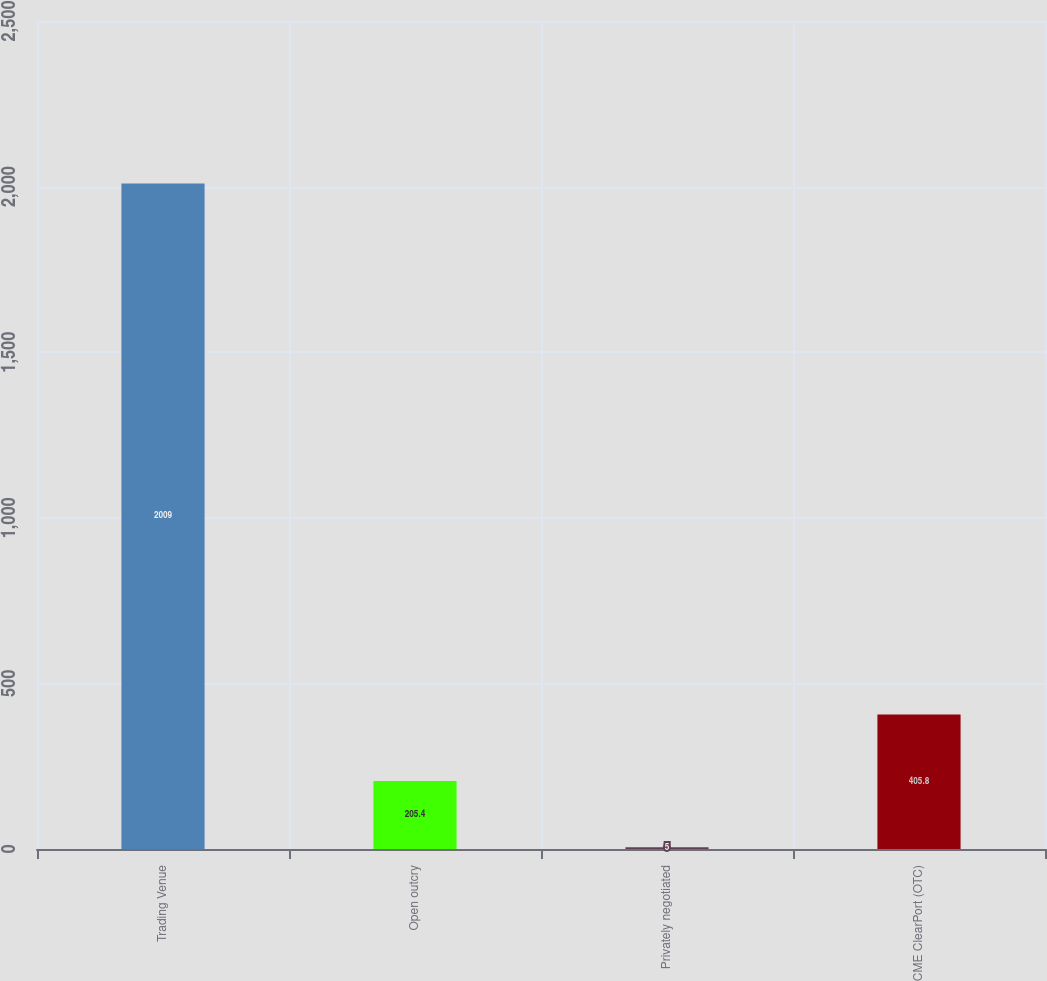<chart> <loc_0><loc_0><loc_500><loc_500><bar_chart><fcel>Trading Venue<fcel>Open outcry<fcel>Privately negotiated<fcel>CME ClearPort (OTC)<nl><fcel>2009<fcel>205.4<fcel>5<fcel>405.8<nl></chart> 